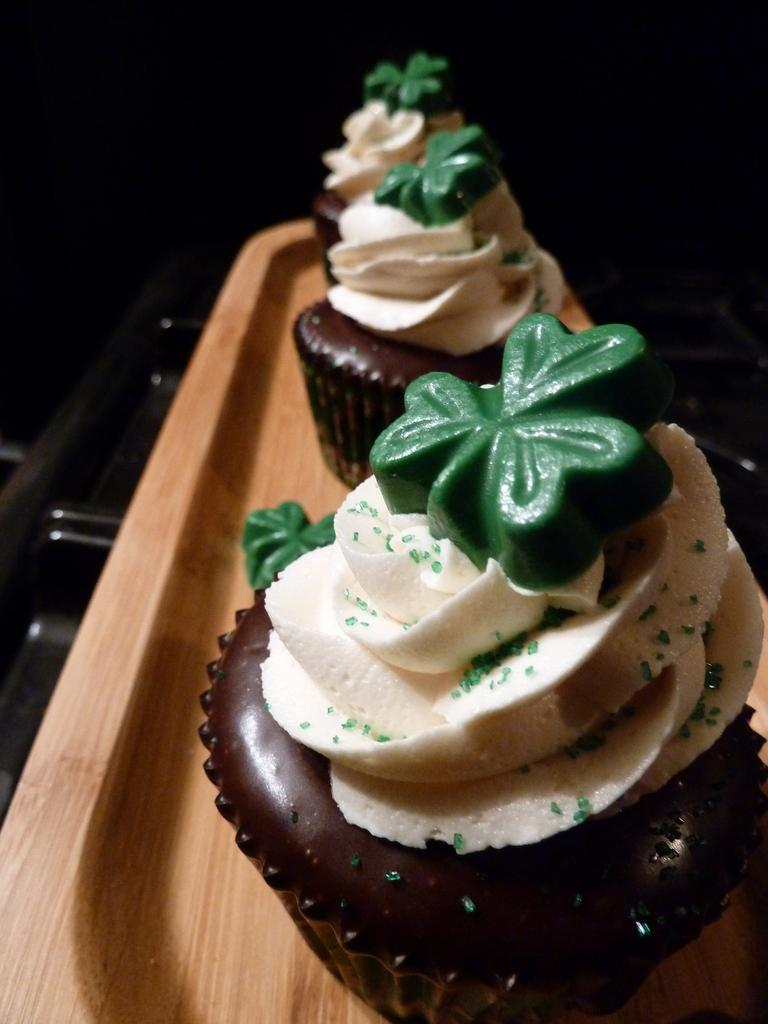What type of food is shown in the image? There are cupcakes in the image. What colors are the cupcakes? The cupcakes are in brown and white colors. How are the cupcakes arranged in the image? The cupcakes are placed in a wooden tray. What can be observed about the background of the image? The background of the image is dark. What type of destruction is happening to the cabbage in the image? There is no cabbage present in the image, and no destruction is occurring. How many legs can be seen on the cupcakes in the image? Cupcakes do not have legs, so this question cannot be answered. 